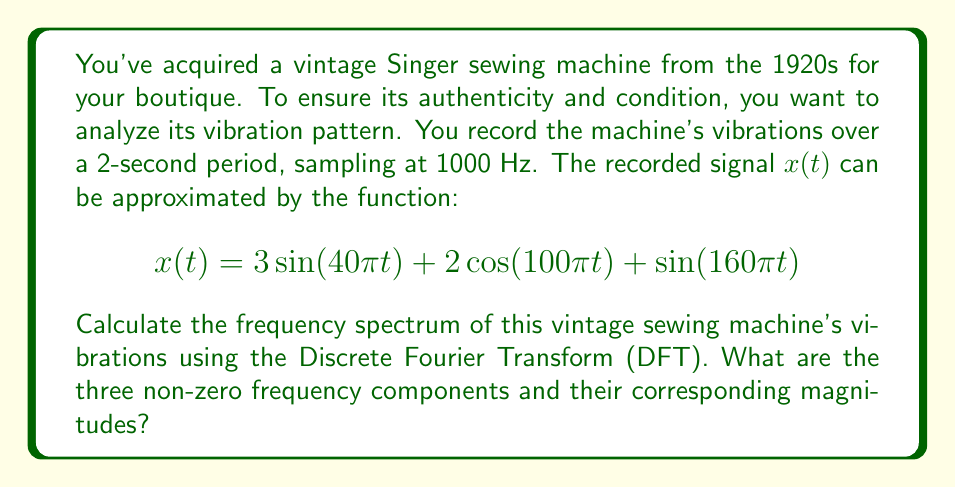Can you solve this math problem? To solve this problem, we'll follow these steps:

1) First, we need to identify the frequencies in the given function. For a sinusoidal function $\sin(2\pi ft)$ or $\cos(2\pi ft)$, the frequency $f$ is the coefficient of $t$ divided by $2\pi$. So we have:

   - $40\pi t$: $f_1 = 40\pi/(2\pi) = 20$ Hz
   - $100\pi t$: $f_2 = 100\pi/(2\pi) = 50$ Hz
   - $160\pi t$: $f_3 = 160\pi/(2\pi) = 80$ Hz

2) The DFT will give us the magnitude of each frequency component. For a continuous signal of the form $A\sin(2\pi ft)$ or $A\cos(2\pi ft)$, the magnitude in the frequency spectrum would be $A/2$ for positive frequencies.

3) Therefore, the magnitudes for each component are:

   - For $3\sin(40\pi t)$: $3/2 = 1.5$
   - For $2\cos(100\pi t)$: $2/2 = 1$
   - For $\sin(160\pi t)$: $1/2 = 0.5$

4) The DFT will show these magnitudes at the corresponding positive frequencies.

Note: In practice, the DFT of a sampled signal would show some spectral leakage and the exact magnitudes might differ slightly, but for this idealized problem, we assume perfect reconstruction.
Answer: The three non-zero frequency components and their corresponding magnitudes are:

20 Hz: 1.5
50 Hz: 1.0
80 Hz: 0.5 